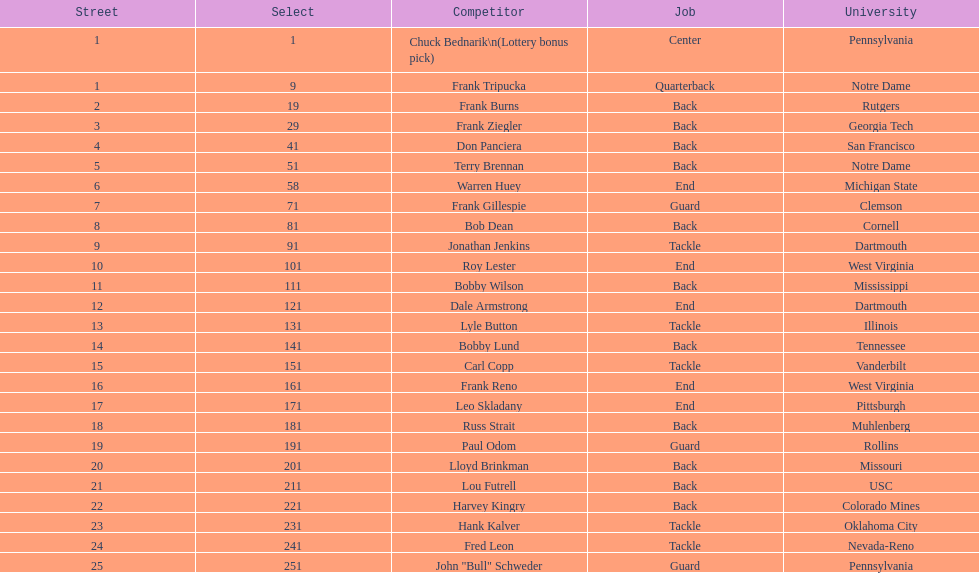Highest rd number? 25. 